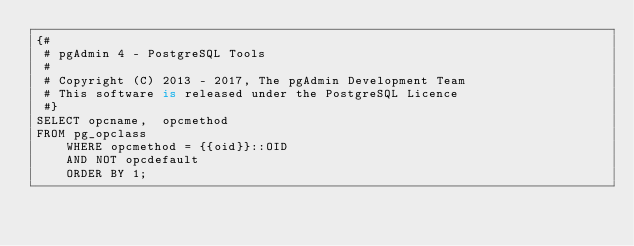Convert code to text. <code><loc_0><loc_0><loc_500><loc_500><_SQL_>{#
 # pgAdmin 4 - PostgreSQL Tools
 #
 # Copyright (C) 2013 - 2017, The pgAdmin Development Team
 # This software is released under the PostgreSQL Licence
 #}
SELECT opcname,  opcmethod
FROM pg_opclass
    WHERE opcmethod = {{oid}}::OID
    AND NOT opcdefault
    ORDER BY 1;</code> 